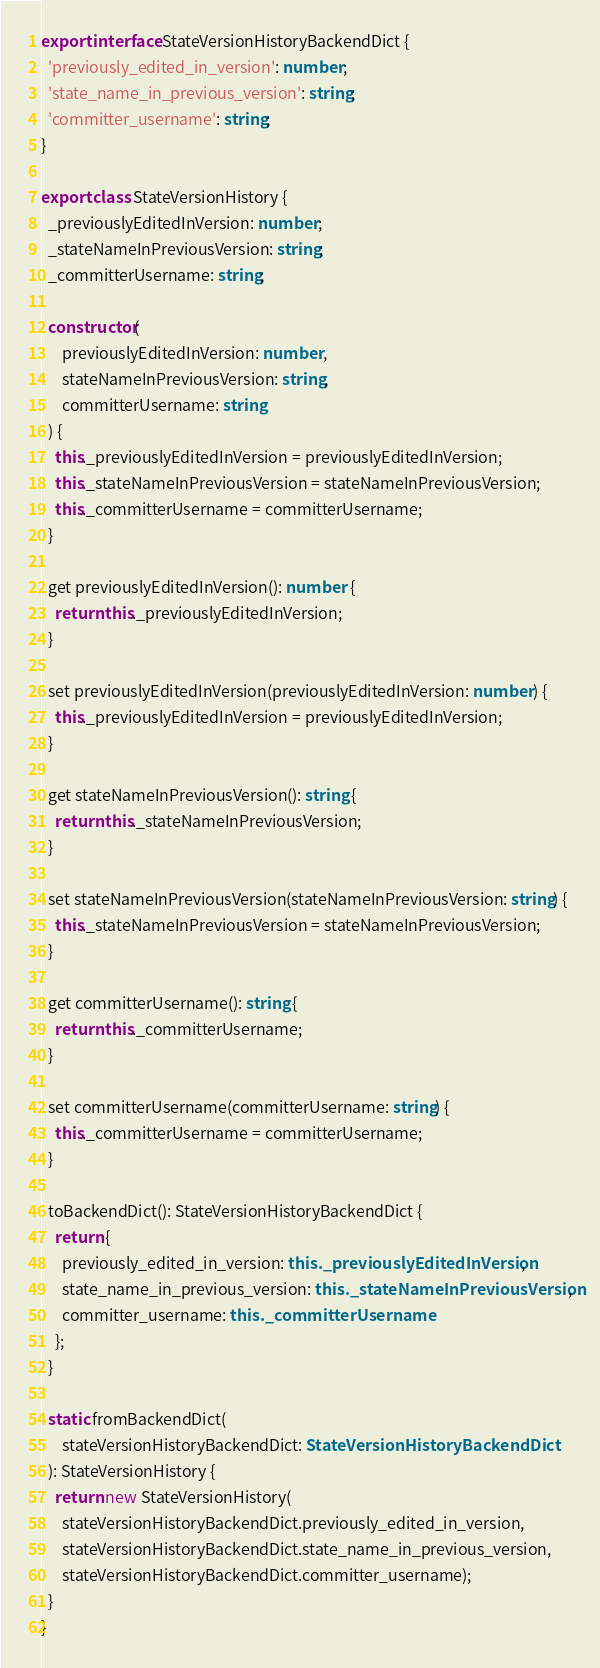<code> <loc_0><loc_0><loc_500><loc_500><_TypeScript_>
export interface StateVersionHistoryBackendDict {
  'previously_edited_in_version': number;
  'state_name_in_previous_version': string;
  'committer_username': string;
}

export class StateVersionHistory {
  _previouslyEditedInVersion: number;
  _stateNameInPreviousVersion: string;
  _committerUsername: string;

  constructor(
      previouslyEditedInVersion: number,
      stateNameInPreviousVersion: string,
      committerUsername: string
  ) {
    this._previouslyEditedInVersion = previouslyEditedInVersion;
    this._stateNameInPreviousVersion = stateNameInPreviousVersion;
    this._committerUsername = committerUsername;
  }

  get previouslyEditedInVersion(): number {
    return this._previouslyEditedInVersion;
  }

  set previouslyEditedInVersion(previouslyEditedInVersion: number) {
    this._previouslyEditedInVersion = previouslyEditedInVersion;
  }

  get stateNameInPreviousVersion(): string {
    return this._stateNameInPreviousVersion;
  }

  set stateNameInPreviousVersion(stateNameInPreviousVersion: string) {
    this._stateNameInPreviousVersion = stateNameInPreviousVersion;
  }

  get committerUsername(): string {
    return this._committerUsername;
  }

  set committerUsername(committerUsername: string) {
    this._committerUsername = committerUsername;
  }

  toBackendDict(): StateVersionHistoryBackendDict {
    return {
      previously_edited_in_version: this._previouslyEditedInVersion,
      state_name_in_previous_version: this._stateNameInPreviousVersion,
      committer_username: this._committerUsername
    };
  }

  static fromBackendDict(
      stateVersionHistoryBackendDict: StateVersionHistoryBackendDict
  ): StateVersionHistory {
    return new StateVersionHistory(
      stateVersionHistoryBackendDict.previously_edited_in_version,
      stateVersionHistoryBackendDict.state_name_in_previous_version,
      stateVersionHistoryBackendDict.committer_username);
  }
}
</code> 